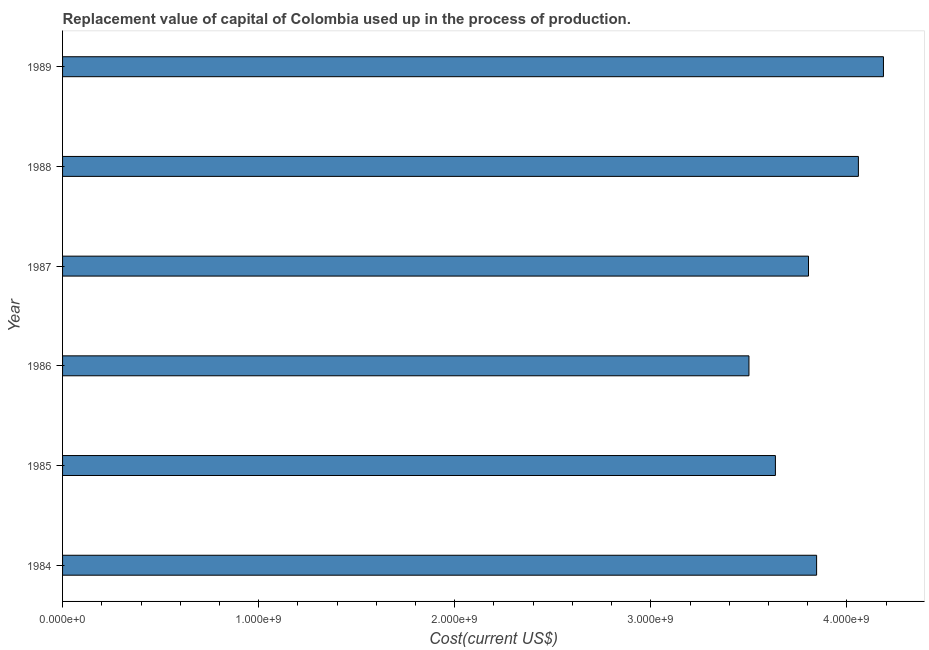Does the graph contain any zero values?
Make the answer very short. No. Does the graph contain grids?
Provide a short and direct response. No. What is the title of the graph?
Your answer should be very brief. Replacement value of capital of Colombia used up in the process of production. What is the label or title of the X-axis?
Ensure brevity in your answer.  Cost(current US$). What is the consumption of fixed capital in 1984?
Your answer should be very brief. 3.85e+09. Across all years, what is the maximum consumption of fixed capital?
Ensure brevity in your answer.  4.19e+09. Across all years, what is the minimum consumption of fixed capital?
Provide a short and direct response. 3.50e+09. What is the sum of the consumption of fixed capital?
Offer a terse response. 2.30e+1. What is the difference between the consumption of fixed capital in 1985 and 1988?
Ensure brevity in your answer.  -4.23e+08. What is the average consumption of fixed capital per year?
Provide a succinct answer. 3.84e+09. What is the median consumption of fixed capital?
Keep it short and to the point. 3.82e+09. In how many years, is the consumption of fixed capital greater than 1800000000 US$?
Offer a terse response. 6. What is the ratio of the consumption of fixed capital in 1985 to that in 1989?
Your answer should be very brief. 0.87. Is the consumption of fixed capital in 1984 less than that in 1988?
Your answer should be very brief. Yes. Is the difference between the consumption of fixed capital in 1986 and 1989 greater than the difference between any two years?
Provide a succinct answer. Yes. What is the difference between the highest and the second highest consumption of fixed capital?
Ensure brevity in your answer.  1.28e+08. What is the difference between the highest and the lowest consumption of fixed capital?
Offer a very short reply. 6.86e+08. In how many years, is the consumption of fixed capital greater than the average consumption of fixed capital taken over all years?
Your response must be concise. 3. Are all the bars in the graph horizontal?
Your answer should be compact. Yes. How many years are there in the graph?
Your response must be concise. 6. What is the Cost(current US$) in 1984?
Offer a very short reply. 3.85e+09. What is the Cost(current US$) of 1985?
Your answer should be compact. 3.64e+09. What is the Cost(current US$) of 1986?
Provide a succinct answer. 3.50e+09. What is the Cost(current US$) in 1987?
Give a very brief answer. 3.80e+09. What is the Cost(current US$) of 1988?
Offer a terse response. 4.06e+09. What is the Cost(current US$) of 1989?
Provide a short and direct response. 4.19e+09. What is the difference between the Cost(current US$) in 1984 and 1985?
Keep it short and to the point. 2.10e+08. What is the difference between the Cost(current US$) in 1984 and 1986?
Offer a very short reply. 3.45e+08. What is the difference between the Cost(current US$) in 1984 and 1987?
Provide a short and direct response. 4.14e+07. What is the difference between the Cost(current US$) in 1984 and 1988?
Give a very brief answer. -2.13e+08. What is the difference between the Cost(current US$) in 1984 and 1989?
Offer a terse response. -3.41e+08. What is the difference between the Cost(current US$) in 1985 and 1986?
Offer a very short reply. 1.35e+08. What is the difference between the Cost(current US$) in 1985 and 1987?
Your answer should be very brief. -1.69e+08. What is the difference between the Cost(current US$) in 1985 and 1988?
Your response must be concise. -4.23e+08. What is the difference between the Cost(current US$) in 1985 and 1989?
Ensure brevity in your answer.  -5.51e+08. What is the difference between the Cost(current US$) in 1986 and 1987?
Give a very brief answer. -3.04e+08. What is the difference between the Cost(current US$) in 1986 and 1988?
Give a very brief answer. -5.58e+08. What is the difference between the Cost(current US$) in 1986 and 1989?
Offer a very short reply. -6.86e+08. What is the difference between the Cost(current US$) in 1987 and 1988?
Keep it short and to the point. -2.54e+08. What is the difference between the Cost(current US$) in 1987 and 1989?
Ensure brevity in your answer.  -3.82e+08. What is the difference between the Cost(current US$) in 1988 and 1989?
Your answer should be compact. -1.28e+08. What is the ratio of the Cost(current US$) in 1984 to that in 1985?
Provide a succinct answer. 1.06. What is the ratio of the Cost(current US$) in 1984 to that in 1986?
Your answer should be compact. 1.1. What is the ratio of the Cost(current US$) in 1984 to that in 1987?
Offer a very short reply. 1.01. What is the ratio of the Cost(current US$) in 1984 to that in 1988?
Offer a very short reply. 0.95. What is the ratio of the Cost(current US$) in 1984 to that in 1989?
Ensure brevity in your answer.  0.92. What is the ratio of the Cost(current US$) in 1985 to that in 1986?
Ensure brevity in your answer.  1.04. What is the ratio of the Cost(current US$) in 1985 to that in 1987?
Offer a terse response. 0.96. What is the ratio of the Cost(current US$) in 1985 to that in 1988?
Your answer should be very brief. 0.9. What is the ratio of the Cost(current US$) in 1985 to that in 1989?
Provide a succinct answer. 0.87. What is the ratio of the Cost(current US$) in 1986 to that in 1987?
Your answer should be compact. 0.92. What is the ratio of the Cost(current US$) in 1986 to that in 1988?
Ensure brevity in your answer.  0.86. What is the ratio of the Cost(current US$) in 1986 to that in 1989?
Your answer should be very brief. 0.84. What is the ratio of the Cost(current US$) in 1987 to that in 1988?
Give a very brief answer. 0.94. What is the ratio of the Cost(current US$) in 1987 to that in 1989?
Your answer should be compact. 0.91. 